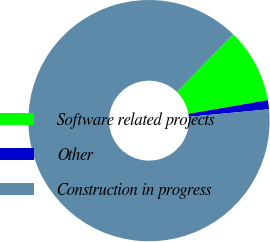Convert chart. <chart><loc_0><loc_0><loc_500><loc_500><pie_chart><fcel>Software related projects<fcel>Other<fcel>Construction in progress<nl><fcel>9.98%<fcel>1.22%<fcel>88.8%<nl></chart> 